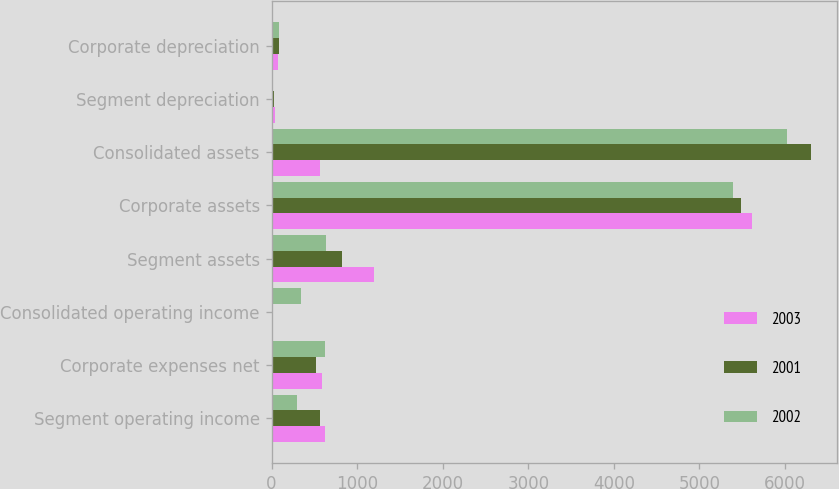<chart> <loc_0><loc_0><loc_500><loc_500><stacked_bar_chart><ecel><fcel>Segment operating income<fcel>Corporate expenses net<fcel>Consolidated operating income<fcel>Segment assets<fcel>Corporate assets<fcel>Consolidated assets<fcel>Segment depreciation<fcel>Corporate depreciation<nl><fcel>2003<fcel>620<fcel>595<fcel>1<fcel>1197<fcel>5618<fcel>562<fcel>39<fcel>74<nl><fcel>2001<fcel>562<fcel>514<fcel>17<fcel>818<fcel>5480<fcel>6298<fcel>28<fcel>86<nl><fcel>2002<fcel>297<fcel>630<fcel>344<fcel>631<fcel>5390<fcel>6021<fcel>16<fcel>84<nl></chart> 